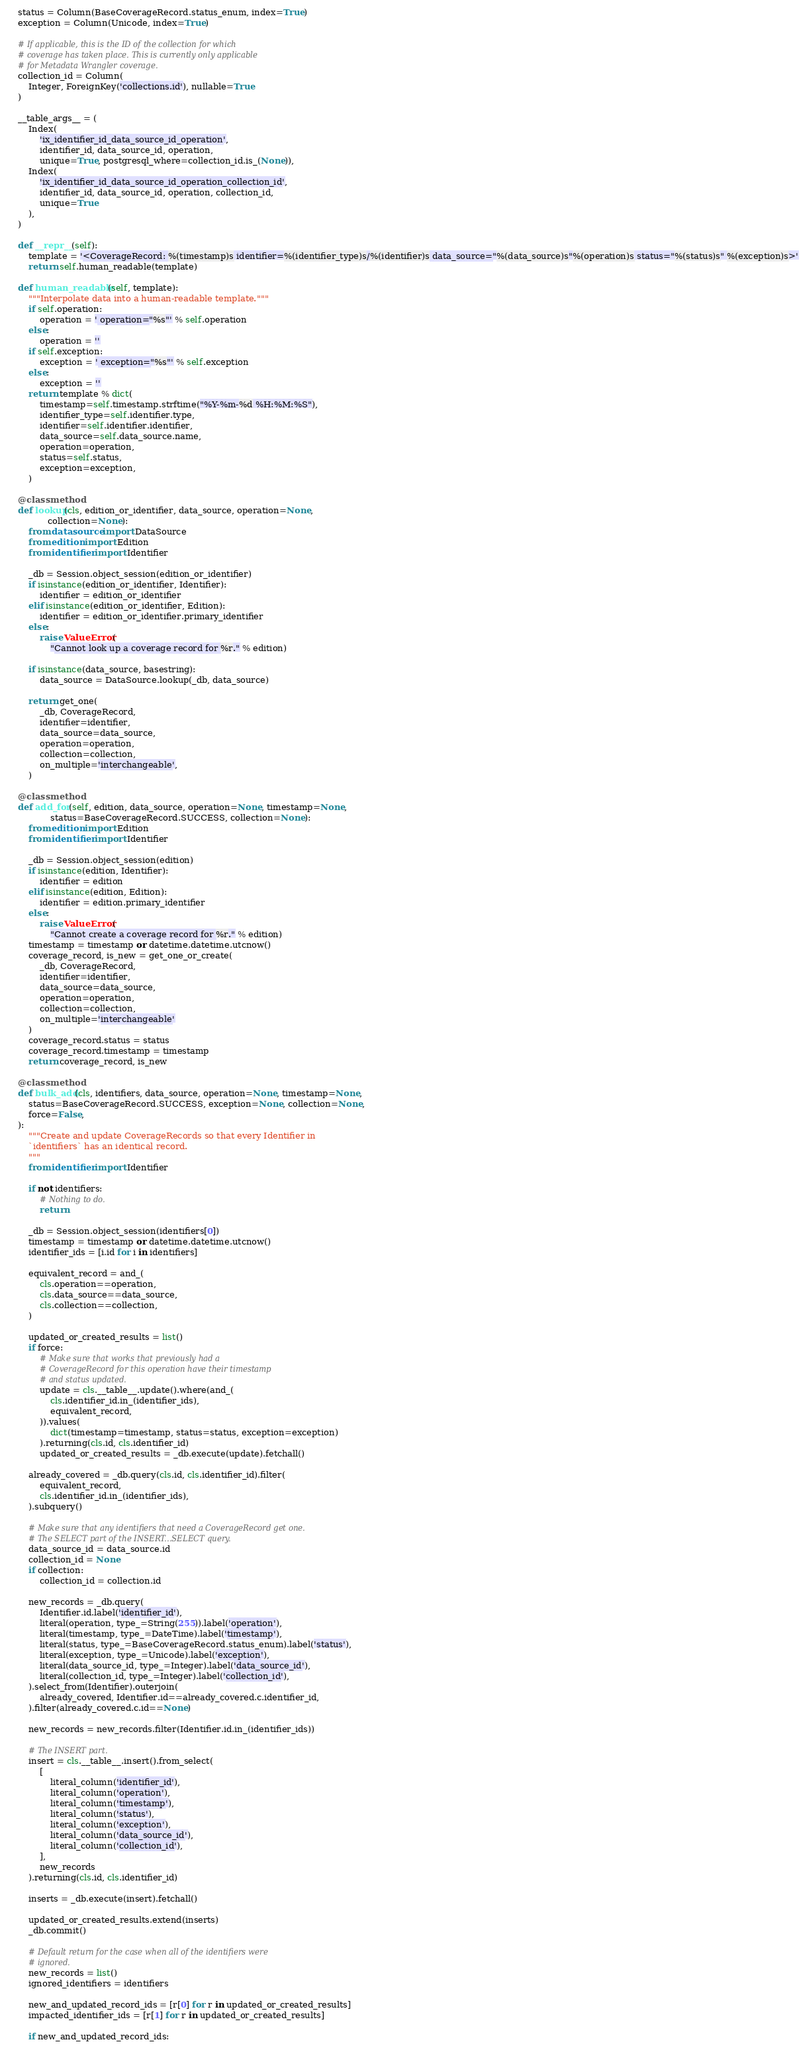<code> <loc_0><loc_0><loc_500><loc_500><_Python_>
    status = Column(BaseCoverageRecord.status_enum, index=True)
    exception = Column(Unicode, index=True)

    # If applicable, this is the ID of the collection for which
    # coverage has taken place. This is currently only applicable
    # for Metadata Wrangler coverage.
    collection_id = Column(
        Integer, ForeignKey('collections.id'), nullable=True
    )

    __table_args__ = (
        Index(
            'ix_identifier_id_data_source_id_operation',
            identifier_id, data_source_id, operation,
            unique=True, postgresql_where=collection_id.is_(None)),
        Index(
            'ix_identifier_id_data_source_id_operation_collection_id',
            identifier_id, data_source_id, operation, collection_id,
            unique=True
        ),
    )

    def __repr__(self):
        template = '<CoverageRecord: %(timestamp)s identifier=%(identifier_type)s/%(identifier)s data_source="%(data_source)s"%(operation)s status="%(status)s" %(exception)s>'
        return self.human_readable(template)

    def human_readable(self, template):
        """Interpolate data into a human-readable template."""
        if self.operation:
            operation = ' operation="%s"' % self.operation
        else:
            operation = ''
        if self.exception:
            exception = ' exception="%s"' % self.exception
        else:
            exception = ''
        return template % dict(
            timestamp=self.timestamp.strftime("%Y-%m-%d %H:%M:%S"),
            identifier_type=self.identifier.type,
            identifier=self.identifier.identifier,
            data_source=self.data_source.name,
            operation=operation,
            status=self.status,
            exception=exception,
        )

    @classmethod
    def lookup(cls, edition_or_identifier, data_source, operation=None,
               collection=None):
        from datasource import DataSource
        from edition import Edition
        from identifier import Identifier

        _db = Session.object_session(edition_or_identifier)
        if isinstance(edition_or_identifier, Identifier):
            identifier = edition_or_identifier
        elif isinstance(edition_or_identifier, Edition):
            identifier = edition_or_identifier.primary_identifier
        else:
            raise ValueError(
                "Cannot look up a coverage record for %r." % edition)

        if isinstance(data_source, basestring):
            data_source = DataSource.lookup(_db, data_source)

        return get_one(
            _db, CoverageRecord,
            identifier=identifier,
            data_source=data_source,
            operation=operation,
            collection=collection,
            on_multiple='interchangeable',
        )

    @classmethod
    def add_for(self, edition, data_source, operation=None, timestamp=None,
                status=BaseCoverageRecord.SUCCESS, collection=None):
        from edition import Edition
        from identifier import Identifier

        _db = Session.object_session(edition)
        if isinstance(edition, Identifier):
            identifier = edition
        elif isinstance(edition, Edition):
            identifier = edition.primary_identifier
        else:
            raise ValueError(
                "Cannot create a coverage record for %r." % edition)
        timestamp = timestamp or datetime.datetime.utcnow()
        coverage_record, is_new = get_one_or_create(
            _db, CoverageRecord,
            identifier=identifier,
            data_source=data_source,
            operation=operation,
            collection=collection,
            on_multiple='interchangeable'
        )
        coverage_record.status = status
        coverage_record.timestamp = timestamp
        return coverage_record, is_new

    @classmethod
    def bulk_add(cls, identifiers, data_source, operation=None, timestamp=None,
        status=BaseCoverageRecord.SUCCESS, exception=None, collection=None,
        force=False,
    ):
        """Create and update CoverageRecords so that every Identifier in
        `identifiers` has an identical record.
        """
        from identifier import Identifier

        if not identifiers:
            # Nothing to do.
            return

        _db = Session.object_session(identifiers[0])
        timestamp = timestamp or datetime.datetime.utcnow()
        identifier_ids = [i.id for i in identifiers]

        equivalent_record = and_(
            cls.operation==operation,
            cls.data_source==data_source,
            cls.collection==collection,
        )

        updated_or_created_results = list()
        if force:
            # Make sure that works that previously had a
            # CoverageRecord for this operation have their timestamp
            # and status updated.
            update = cls.__table__.update().where(and_(
                cls.identifier_id.in_(identifier_ids),
                equivalent_record,
            )).values(
                dict(timestamp=timestamp, status=status, exception=exception)
            ).returning(cls.id, cls.identifier_id)
            updated_or_created_results = _db.execute(update).fetchall()

        already_covered = _db.query(cls.id, cls.identifier_id).filter(
            equivalent_record,
            cls.identifier_id.in_(identifier_ids),
        ).subquery()

        # Make sure that any identifiers that need a CoverageRecord get one.
        # The SELECT part of the INSERT...SELECT query.
        data_source_id = data_source.id
        collection_id = None
        if collection:
            collection_id = collection.id

        new_records = _db.query(
            Identifier.id.label('identifier_id'),
            literal(operation, type_=String(255)).label('operation'),
            literal(timestamp, type_=DateTime).label('timestamp'),
            literal(status, type_=BaseCoverageRecord.status_enum).label('status'),
            literal(exception, type_=Unicode).label('exception'),
            literal(data_source_id, type_=Integer).label('data_source_id'),
            literal(collection_id, type_=Integer).label('collection_id'),
        ).select_from(Identifier).outerjoin(
            already_covered, Identifier.id==already_covered.c.identifier_id,
        ).filter(already_covered.c.id==None)

        new_records = new_records.filter(Identifier.id.in_(identifier_ids))

        # The INSERT part.
        insert = cls.__table__.insert().from_select(
            [
                literal_column('identifier_id'),
                literal_column('operation'),
                literal_column('timestamp'),
                literal_column('status'),
                literal_column('exception'),
                literal_column('data_source_id'),
                literal_column('collection_id'),
            ],
            new_records
        ).returning(cls.id, cls.identifier_id)

        inserts = _db.execute(insert).fetchall()

        updated_or_created_results.extend(inserts)
        _db.commit()

        # Default return for the case when all of the identifiers were
        # ignored.
        new_records = list()
        ignored_identifiers = identifiers

        new_and_updated_record_ids = [r[0] for r in updated_or_created_results]
        impacted_identifier_ids = [r[1] for r in updated_or_created_results]

        if new_and_updated_record_ids:</code> 